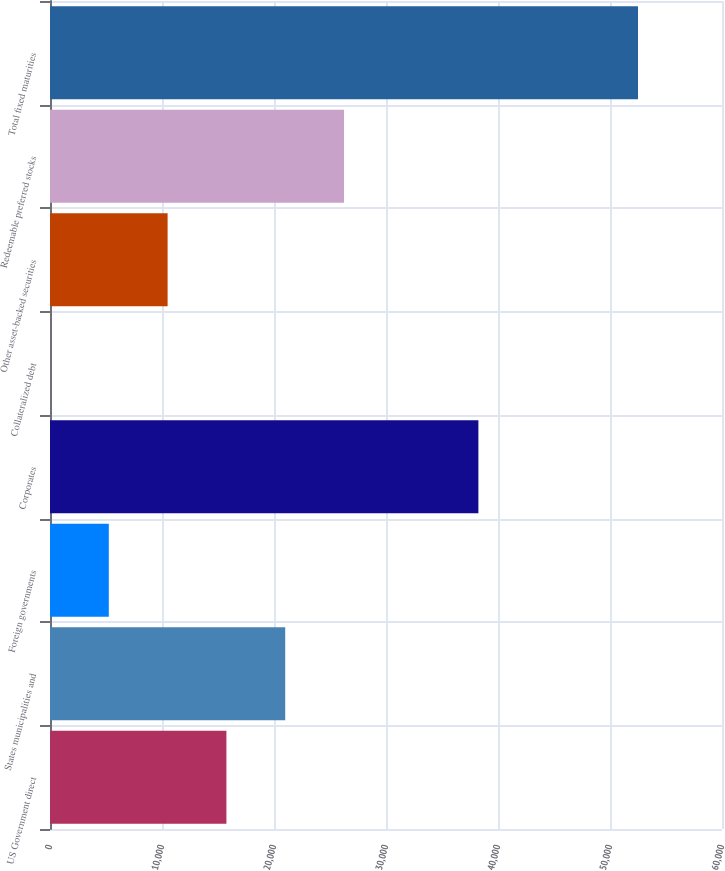Convert chart to OTSL. <chart><loc_0><loc_0><loc_500><loc_500><bar_chart><fcel>US Government direct<fcel>States municipalities and<fcel>Foreign governments<fcel>Corporates<fcel>Collateralized debt<fcel>Other asset-backed securities<fcel>Redeemable preferred stocks<fcel>Total fixed maturities<nl><fcel>15750.8<fcel>21001<fcel>5250.49<fcel>38249<fcel>0.32<fcel>10500.7<fcel>26251.2<fcel>52502<nl></chart> 